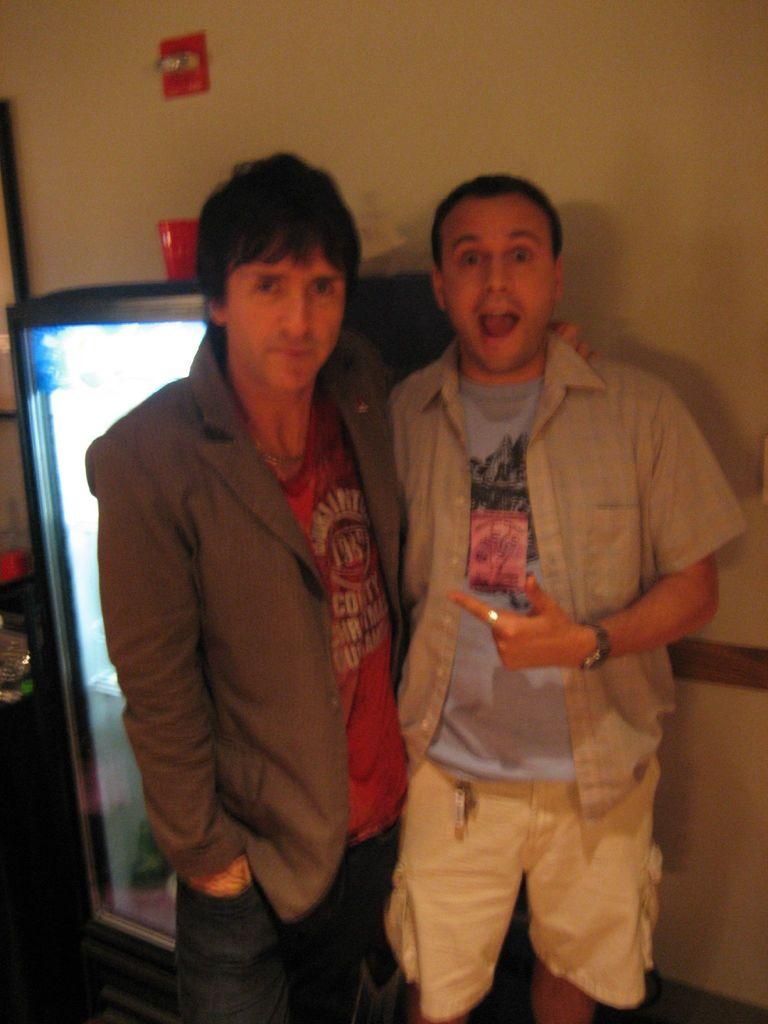How many people are present in the image? There are two people in the image. What type of appliance can be seen in the image? There is a refrigerator in the image. What is the background of the image made of? There is a wall in the image. What device is used for controlling electrical circuits in the image? There is a switchboard in the image. What year is depicted in the image? The image does not depict a specific year; it is a photograph of a scene with people, a refrigerator, a wall, and a switchboard. 